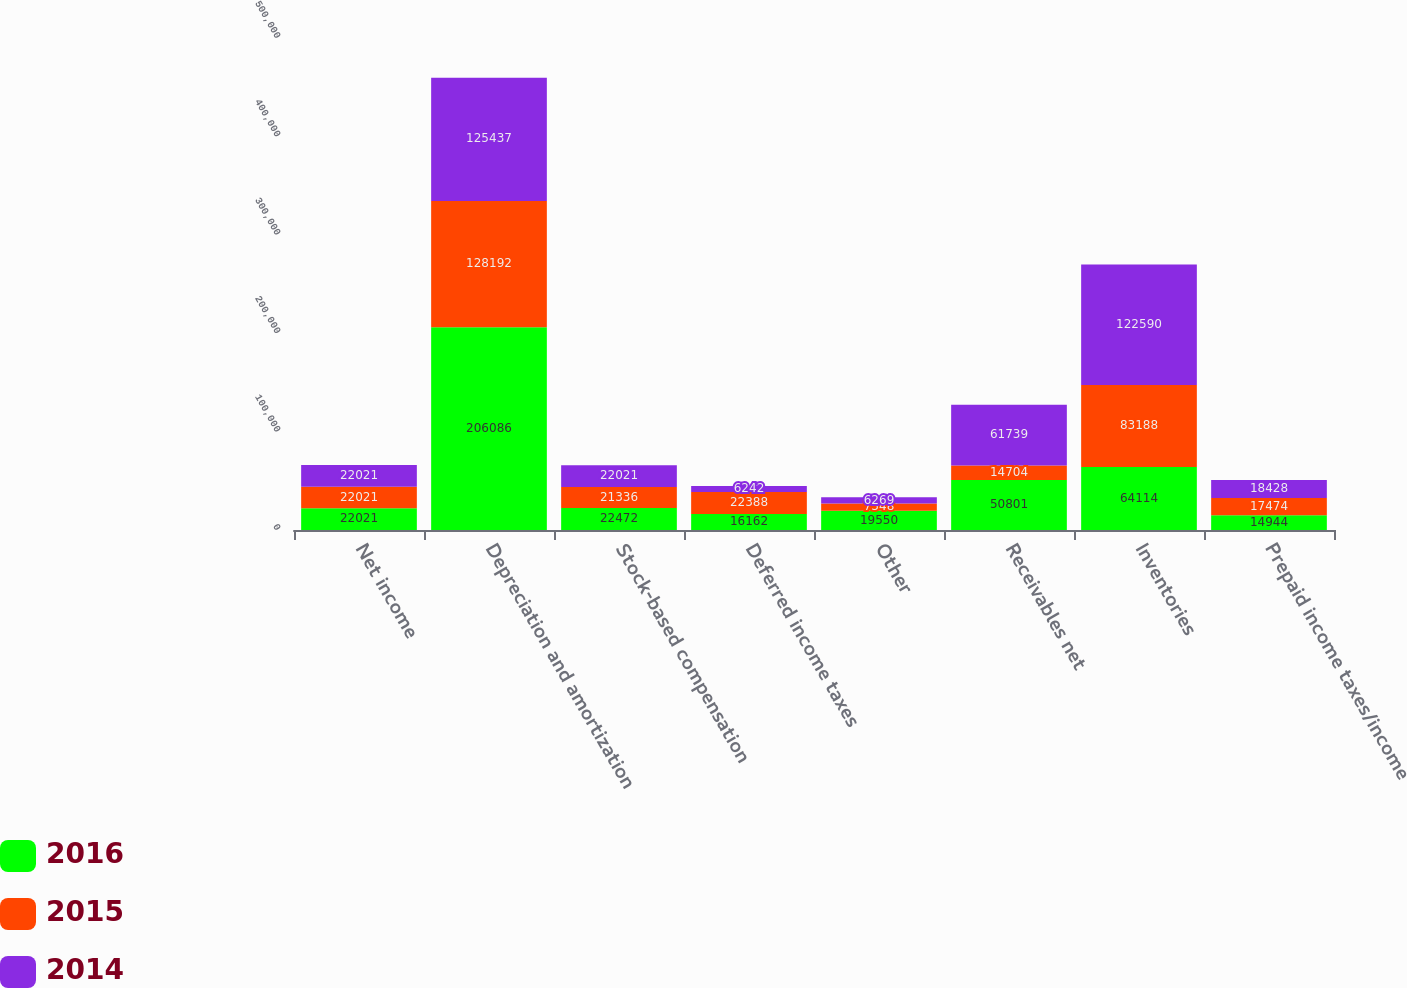Convert chart. <chart><loc_0><loc_0><loc_500><loc_500><stacked_bar_chart><ecel><fcel>Net income<fcel>Depreciation and amortization<fcel>Stock-based compensation<fcel>Deferred income taxes<fcel>Other<fcel>Receivables net<fcel>Inventories<fcel>Prepaid income taxes/income<nl><fcel>2016<fcel>22021<fcel>206086<fcel>22472<fcel>16162<fcel>19550<fcel>50801<fcel>64114<fcel>14944<nl><fcel>2015<fcel>22021<fcel>128192<fcel>21336<fcel>22388<fcel>7348<fcel>14704<fcel>83188<fcel>17474<nl><fcel>2014<fcel>22021<fcel>125437<fcel>22021<fcel>6242<fcel>6269<fcel>61739<fcel>122590<fcel>18428<nl></chart> 